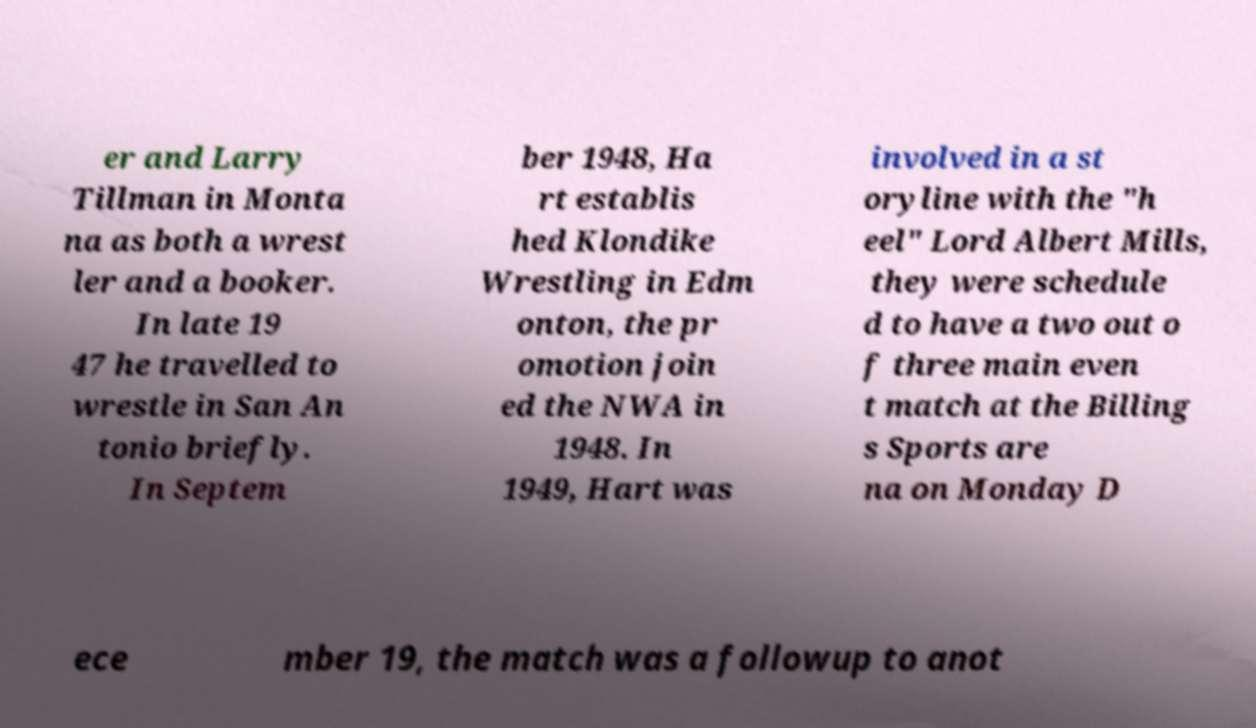There's text embedded in this image that I need extracted. Can you transcribe it verbatim? er and Larry Tillman in Monta na as both a wrest ler and a booker. In late 19 47 he travelled to wrestle in San An tonio briefly. In Septem ber 1948, Ha rt establis hed Klondike Wrestling in Edm onton, the pr omotion join ed the NWA in 1948. In 1949, Hart was involved in a st oryline with the "h eel" Lord Albert Mills, they were schedule d to have a two out o f three main even t match at the Billing s Sports are na on Monday D ece mber 19, the match was a followup to anot 